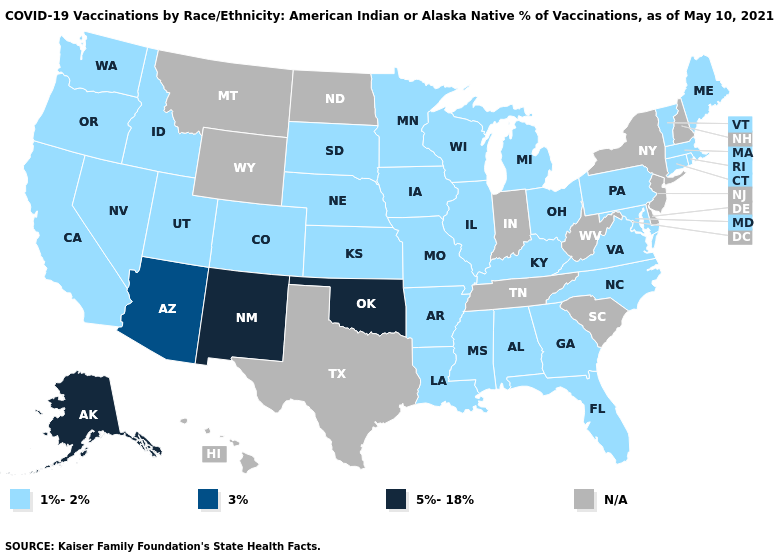What is the lowest value in the South?
Short answer required. 1%-2%. What is the value of Florida?
Short answer required. 1%-2%. Name the states that have a value in the range N/A?
Be succinct. Delaware, Hawaii, Indiana, Montana, New Hampshire, New Jersey, New York, North Dakota, South Carolina, Tennessee, Texas, West Virginia, Wyoming. Which states have the lowest value in the South?
Be succinct. Alabama, Arkansas, Florida, Georgia, Kentucky, Louisiana, Maryland, Mississippi, North Carolina, Virginia. Does the map have missing data?
Write a very short answer. Yes. Does Arizona have the lowest value in the USA?
Short answer required. No. Name the states that have a value in the range N/A?
Concise answer only. Delaware, Hawaii, Indiana, Montana, New Hampshire, New Jersey, New York, North Dakota, South Carolina, Tennessee, Texas, West Virginia, Wyoming. What is the value of Wyoming?
Short answer required. N/A. Among the states that border Idaho , which have the lowest value?
Keep it brief. Nevada, Oregon, Utah, Washington. What is the value of Minnesota?
Be succinct. 1%-2%. Which states have the highest value in the USA?
Short answer required. Alaska, New Mexico, Oklahoma. 